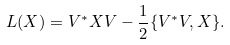Convert formula to latex. <formula><loc_0><loc_0><loc_500><loc_500>L ( X ) = V ^ { * } X V - \frac { 1 } { 2 } \{ V ^ { * } V , X \} .</formula> 